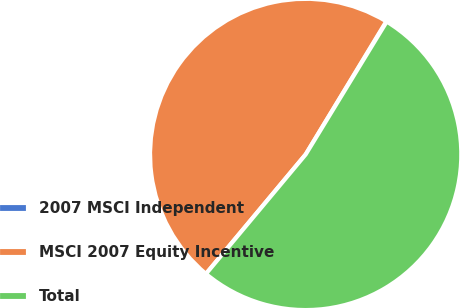Convert chart. <chart><loc_0><loc_0><loc_500><loc_500><pie_chart><fcel>2007 MSCI Independent<fcel>MSCI 2007 Equity Incentive<fcel>Total<nl><fcel>0.05%<fcel>47.59%<fcel>52.35%<nl></chart> 